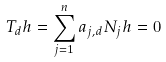<formula> <loc_0><loc_0><loc_500><loc_500>T _ { d } h = \sum _ { j = 1 } ^ { n } a _ { j , d } N _ { j } h = 0</formula> 